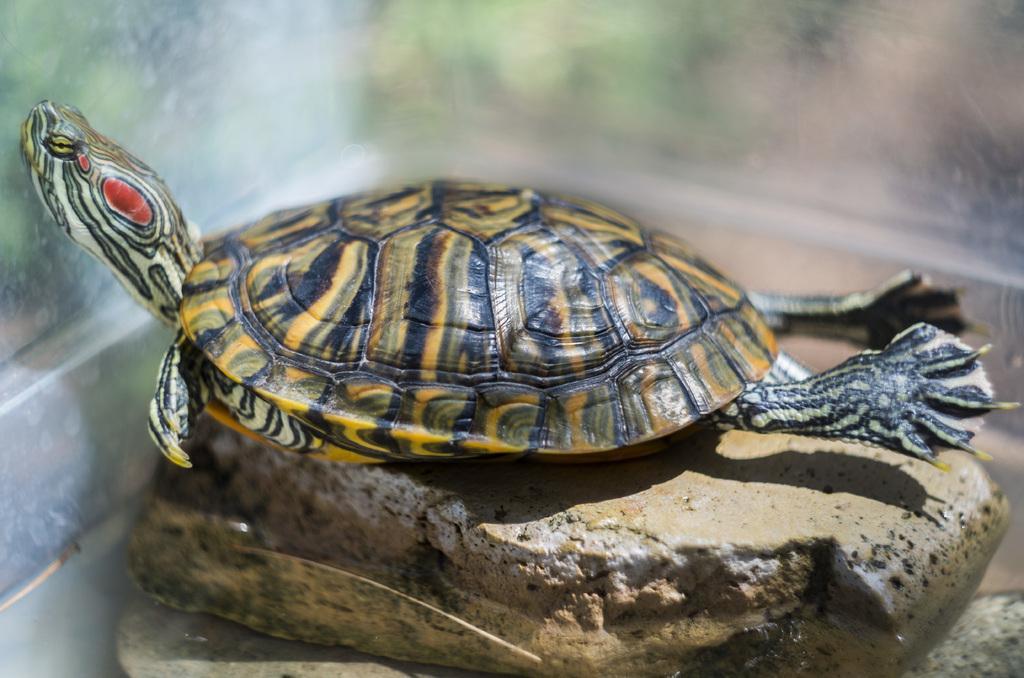How would you summarize this image in a sentence or two? In this image in the center there is a turtle on the stone and the background is blurry. 